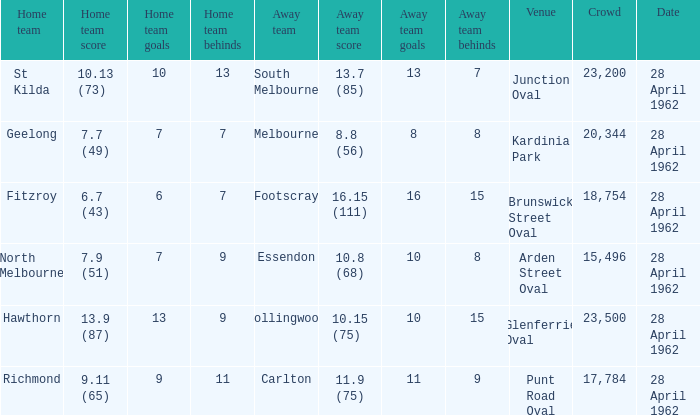What away team played at Brunswick Street Oval? Footscray. 